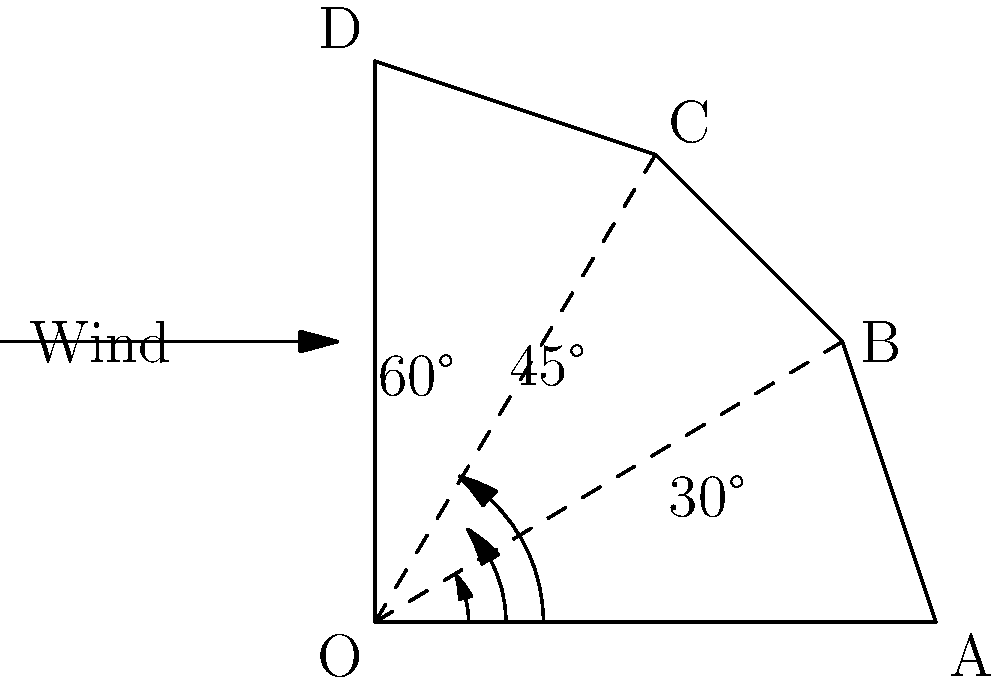As an eco-friendly innovator, you're developing a new wind turbine design. Your research suggests that the efficiency of a wind turbine depends on the angle of its blades. You've narrowed it down to three potential blade angles: 30°, 45°, and 60°. The wind speed is represented by a vector $\mathbf{v} = \langle 10, 0 \rangle$ m/s. Which blade angle will produce the maximum force perpendicular to the wind direction, potentially generating the most power? To solve this problem, we'll follow these steps:

1) The force generated by the wind on the blade can be decomposed into two components: one parallel to the wind direction (which doesn't contribute to the turbine's rotation) and one perpendicular to the wind direction (which does contribute to the rotation).

2) The perpendicular component is what we want to maximize. This component can be calculated using the sine of the blade angle:

   $F_\perp = F \sin \theta$

   where $F$ is the total force and $\theta$ is the blade angle.

3) While we don't know the exact magnitude of $F$, we know it's proportional to the wind speed squared. Since the wind speed is constant in this problem, we can consider $F$ as constant.

4) Therefore, to maximize $F_\perp$, we need to maximize $\sin \theta$.

5) Let's calculate $\sin \theta$ for each angle:

   For 30°: $\sin 30° = 0.5$
   For 45°: $\sin 45° = \frac{1}{\sqrt{2}} \approx 0.707$
   For 60°: $\sin 60° = \frac{\sqrt{3}}{2} \approx 0.866$

6) The largest value is $\sin 60° \approx 0.866$, corresponding to the 60° angle.

Therefore, the 60° blade angle will produce the maximum force perpendicular to the wind direction, potentially generating the most power.
Answer: 60° 